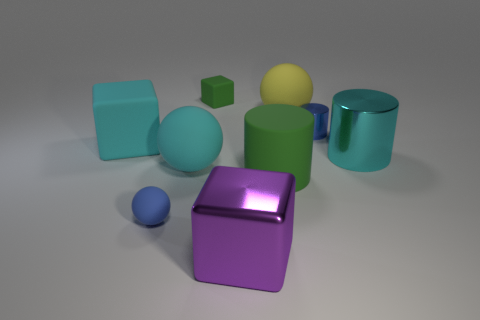What number of tiny things are either red things or blue spheres?
Give a very brief answer. 1. Are there any other things that have the same shape as the blue metal object?
Ensure brevity in your answer.  Yes. What is the color of the other block that is made of the same material as the green block?
Offer a very short reply. Cyan. There is a small rubber thing behind the cyan shiny cylinder; what is its color?
Your answer should be very brief. Green. How many tiny blocks are the same color as the large matte cylinder?
Ensure brevity in your answer.  1. Are there fewer big purple metal cubes on the left side of the small ball than big cyan rubber blocks that are on the left side of the cyan matte block?
Make the answer very short. No. There is a tiny blue metal cylinder; how many big objects are behind it?
Your answer should be compact. 1. Are there any big cyan objects that have the same material as the purple cube?
Keep it short and to the point. Yes. Is the number of large purple shiny blocks behind the tiny block greater than the number of green matte cylinders left of the blue sphere?
Your answer should be compact. No. The green cylinder has what size?
Your answer should be compact. Large. 